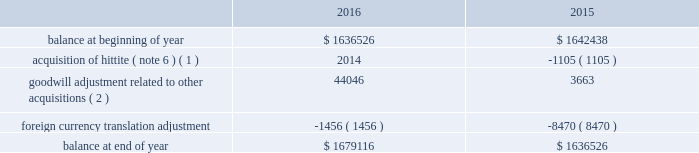Analog devices , inc .
Notes to consolidated financial statements 2014 ( continued ) depreciation expense for property , plant and equipment was $ 134.5 million , $ 130.1 million and $ 114.1 million in fiscal 2016 , 2015 and 2014 , respectively .
The company reviews property , plant and equipment for impairment whenever events or changes in circumstances indicate that the carrying amount of assets may not be recoverable .
Recoverability of these assets is determined by comparison of their carrying amount to the future undiscounted cash flows the assets are expected to generate over their remaining economic lives .
If such assets are considered to be impaired , the impairment to be recognized in earnings equals the amount by which the carrying value of the assets exceeds their fair value determined by either a quoted market price , if any , or a value determined by utilizing a discounted cash flow technique .
If such assets are not impaired , but their useful lives have decreased , the remaining net book value is depreciated over the revised useful life .
We have not recorded any material impairment charges related to our property , plant and equipment in fiscal 2016 , fiscal 2015 or fiscal 2014 .
Goodwill and intangible assets goodwill the company evaluates goodwill for impairment annually , as well as whenever events or changes in circumstances suggest that the carrying value of goodwill may not be recoverable .
The company tests goodwill for impairment at the reporting unit level ( operating segment or one level below an operating segment ) on an annual basis on the first day of the fourth quarter ( on or about august 1 ) or more frequently if indicators of impairment exist .
For the company 2019s latest annual impairment assessment that occurred as of july 31 , 2016 , the company identified its reporting units to be its seven operating segments .
The performance of the test involves a two-step process .
The first step of the quantitative impairment test involves comparing the fair values of the applicable reporting units with their aggregate carrying values , including goodwill .
The company determines the fair value of its reporting units using a weighting of the income and market approaches .
Under the income approach , the company uses a discounted cash flow methodology which requires management to make significant estimates and assumptions related to forecasted revenues , gross profit margins , operating income margins , working capital cash flow , perpetual growth rates , and long-term discount rates , among others .
For the market approach , the company uses the guideline public company method .
Under this method the company utilizes information from comparable publicly traded companies with similar operating and investment characteristics as the reporting units , to create valuation multiples that are applied to the operating performance of the reporting unit being tested , in order to obtain their respective fair values .
In order to assess the reasonableness of the calculated reporting unit fair values , the company reconciles the aggregate fair values of its reporting units determined , as described above , to its current market capitalization , allowing for a reasonable control premium .
If the carrying amount of a reporting unit , calculated using the above approaches , exceeds the reporting unit 2019s fair value , the company performs the second step of the goodwill impairment test to determine the amount of impairment loss .
The second step of the goodwill impairment test involves comparing the implied fair value of the affected reporting unit 2019s goodwill with the carrying value of that reporting unit .
There was no impairment of goodwill in any of the fiscal years presented .
The company 2019s next annual impairment assessment will be performed as of the first day of the fourth quarter of the fiscal year ending october 28 , 2017 ( fiscal 2017 ) unless indicators arise that would require the company to reevaluate at an earlier date .
The table presents the changes in goodwill during fiscal 2016 and fiscal 2015: .
( 1 ) amount in fiscal 2015 represents changes to goodwill as a result of finalizing the acquisition accounting related to the hittite acquisition .
( 2 ) represents goodwill related to other acquisitions that were not material to the company on either an individual or aggregate basis .
Intangible assets the company reviews finite-lived intangible assets for impairment whenever events or changes in circumstances indicate that the carrying value of assets may not be recoverable .
Recoverability of these assets is determined by comparison of their carrying value to the estimated future undiscounted cash flows the assets are expected to generate over their remaining .
How much money can be deducted from income taxes from the 2014 to 2016 , not counting goodwill and intangible assets? 
Rationale: depreciation expenses are able to be deducted from future income taxes therefore based on line 2 the total amount of depreciated expenses was $ 378.7 million . this was found by adding up the total depreciation expenses for 20142015 , and 2016
Computations: (130.1 + (134.5 + 114.1))
Answer: 378.7. 